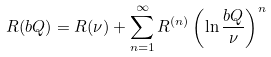Convert formula to latex. <formula><loc_0><loc_0><loc_500><loc_500>R ( b Q ) = R ( \nu ) + \sum _ { n = 1 } ^ { \infty } R ^ { ( n ) } \left ( \ln \frac { b Q } { \nu } \right ) ^ { n }</formula> 